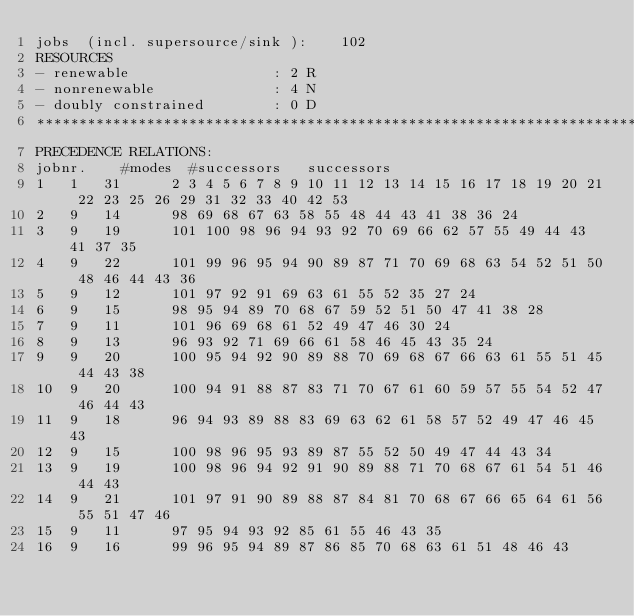<code> <loc_0><loc_0><loc_500><loc_500><_ObjectiveC_>jobs  (incl. supersource/sink ):	102
RESOURCES
- renewable                 : 2 R
- nonrenewable              : 4 N
- doubly constrained        : 0 D
************************************************************************
PRECEDENCE RELATIONS:
jobnr.    #modes  #successors   successors
1	1	31		2 3 4 5 6 7 8 9 10 11 12 13 14 15 16 17 18 19 20 21 22 23 25 26 29 31 32 33 40 42 53 
2	9	14		98 69 68 67 63 58 55 48 44 43 41 38 36 24 
3	9	19		101 100 98 96 94 93 92 70 69 66 62 57 55 49 44 43 41 37 35 
4	9	22		101 99 96 95 94 90 89 87 71 70 69 68 63 54 52 51 50 48 46 44 43 36 
5	9	12		101 97 92 91 69 63 61 55 52 35 27 24 
6	9	15		98 95 94 89 70 68 67 59 52 51 50 47 41 38 28 
7	9	11		101 96 69 68 61 52 49 47 46 30 24 
8	9	13		96 93 92 71 69 66 61 58 46 45 43 35 24 
9	9	20		100 95 94 92 90 89 88 70 69 68 67 66 63 61 55 51 45 44 43 38 
10	9	20		100 94 91 88 87 83 71 70 67 61 60 59 57 55 54 52 47 46 44 43 
11	9	18		96 94 93 89 88 83 69 63 62 61 58 57 52 49 47 46 45 43 
12	9	15		100 98 96 95 93 89 87 55 52 50 49 47 44 43 34 
13	9	19		100 98 96 94 92 91 90 89 88 71 70 68 67 61 54 51 46 44 43 
14	9	21		101 97 91 90 89 88 87 84 81 70 68 67 66 65 64 61 56 55 51 47 46 
15	9	11		97 95 94 93 92 85 61 55 46 43 35 
16	9	16		99 96 95 94 89 87 86 85 70 68 63 61 51 48 46 43 </code> 